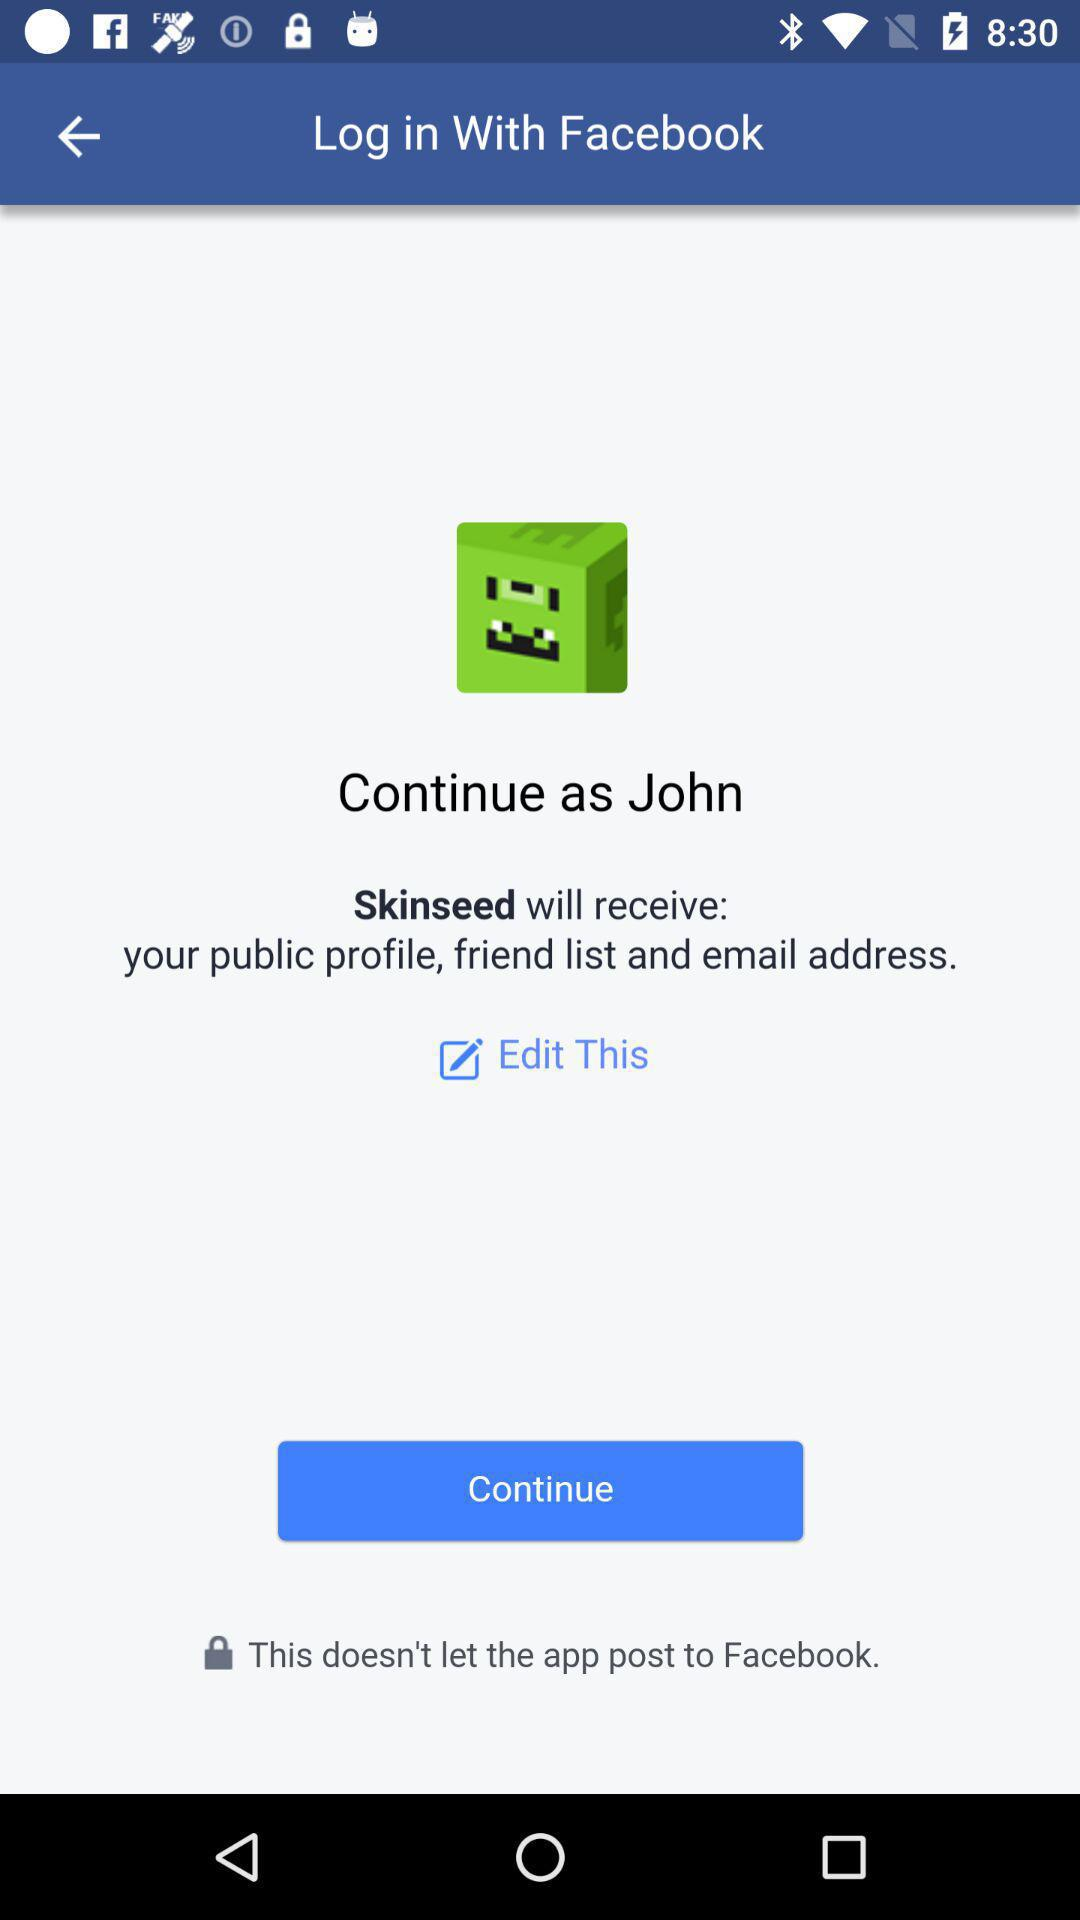Which option is selected?
When the provided information is insufficient, respond with <no answer>. <no answer> 